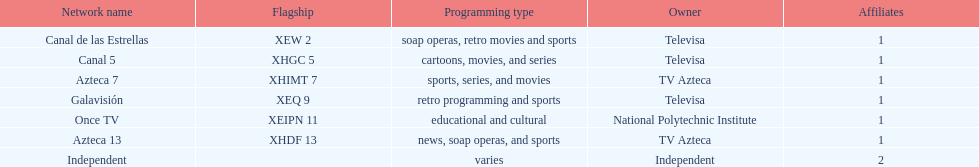Who holds ownership of azteca 7 and azteca 13? TV Azteca. 